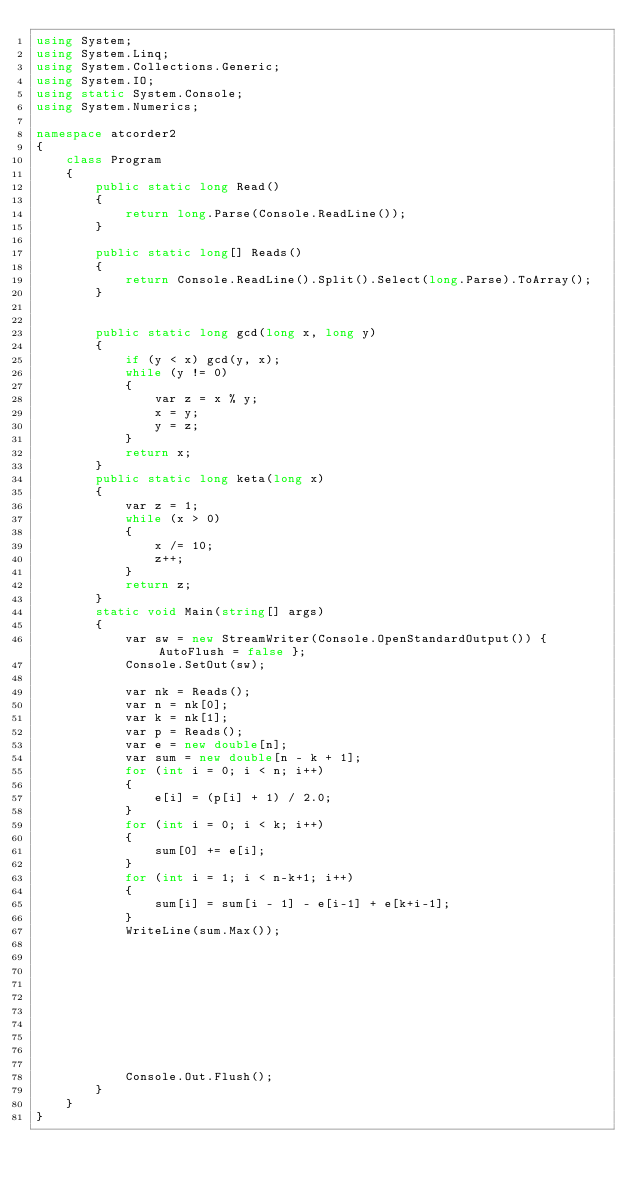<code> <loc_0><loc_0><loc_500><loc_500><_C#_>using System;
using System.Linq;
using System.Collections.Generic;
using System.IO;
using static System.Console;
using System.Numerics;

namespace atcorder2
{
    class Program
    {
        public static long Read()
        {
            return long.Parse(Console.ReadLine());
        }

        public static long[] Reads()
        {
            return Console.ReadLine().Split().Select(long.Parse).ToArray();
        }


        public static long gcd(long x, long y)
        {
            if (y < x) gcd(y, x);
            while (y != 0)
            {
                var z = x % y;
                x = y;
                y = z;
            }
            return x;
        }
        public static long keta(long x)
        {
            var z = 1;
            while (x > 0)
            {
                x /= 10;
                z++;
            }
            return z;
        }
        static void Main(string[] args)
        {
            var sw = new StreamWriter(Console.OpenStandardOutput()) { AutoFlush = false };
            Console.SetOut(sw);

            var nk = Reads();
            var n = nk[0];
            var k = nk[1];
            var p = Reads();
            var e = new double[n];
            var sum = new double[n - k + 1];
            for (int i = 0; i < n; i++)
            {
                e[i] = (p[i] + 1) / 2.0;
            }
            for (int i = 0; i < k; i++)
            {
                sum[0] += e[i];
            }
            for (int i = 1; i < n-k+1; i++)
            {
                sum[i] = sum[i - 1] - e[i-1] + e[k+i-1];
            }
            WriteLine(sum.Max());









          
            Console.Out.Flush();
        }
    }
}

</code> 